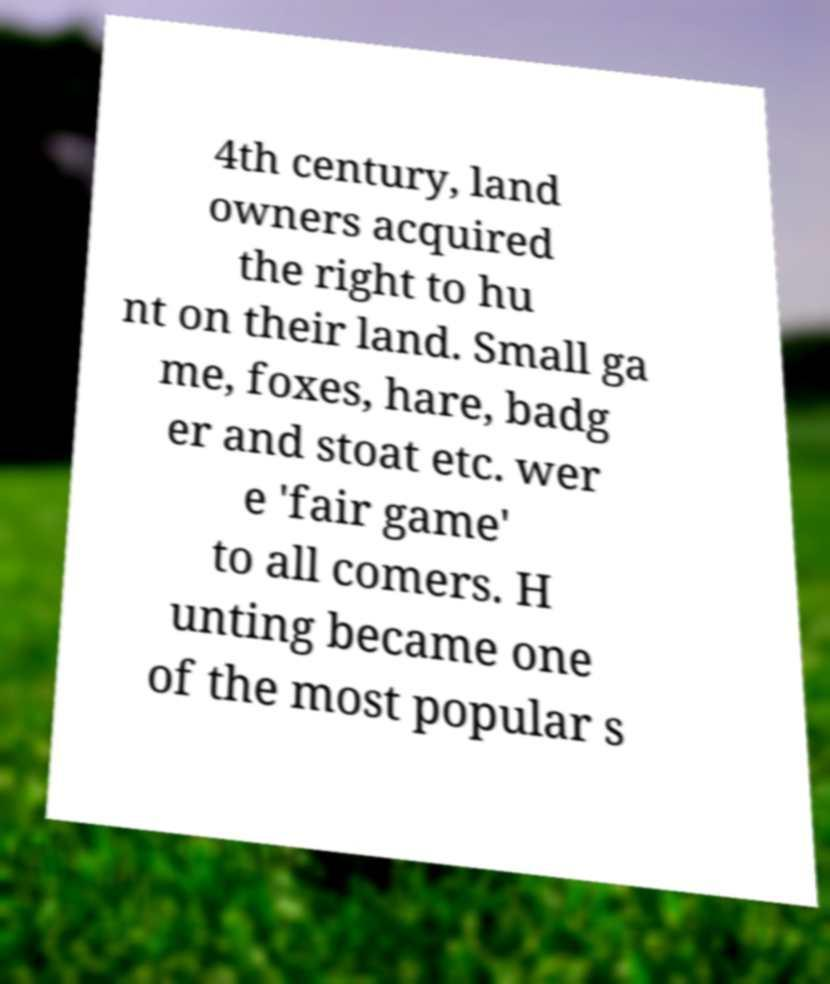I need the written content from this picture converted into text. Can you do that? 4th century, land owners acquired the right to hu nt on their land. Small ga me, foxes, hare, badg er and stoat etc. wer e 'fair game' to all comers. H unting became one of the most popular s 